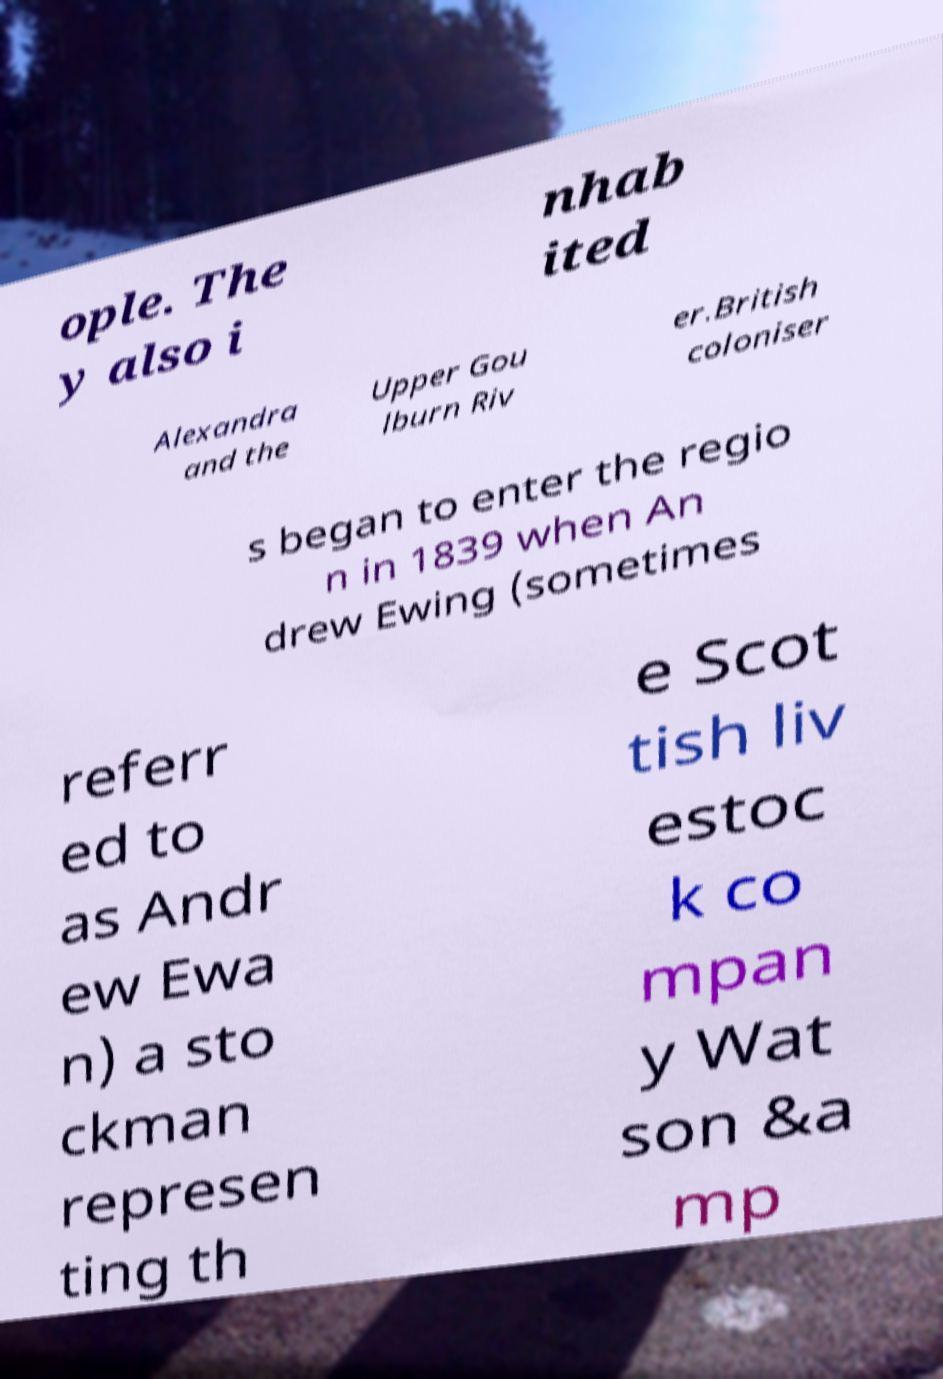Please read and relay the text visible in this image. What does it say? ople. The y also i nhab ited Alexandra and the Upper Gou lburn Riv er.British coloniser s began to enter the regio n in 1839 when An drew Ewing (sometimes referr ed to as Andr ew Ewa n) a sto ckman represen ting th e Scot tish liv estoc k co mpan y Wat son &a mp 